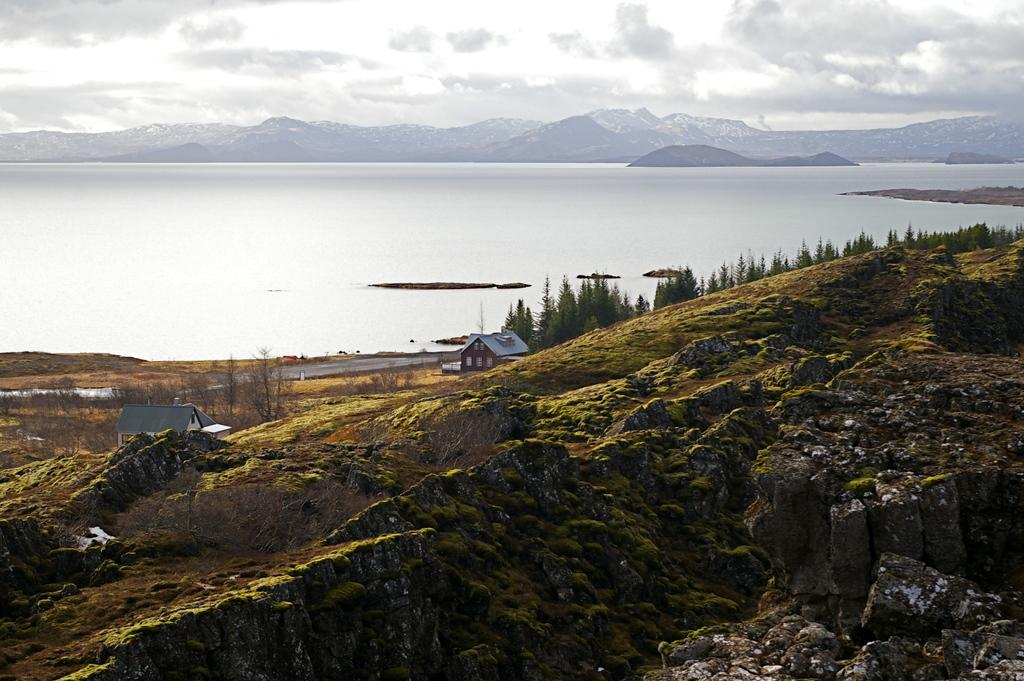What type of vegetation can be seen on the mountain in the image? There is algae on the mountain in the image. What type of structures are present in the image? There are huts in the image. What other natural elements can be seen in the image? There are trees in the image. What can be seen in the background of the image? There is a river, mountains, and the sky visible in the background of the image. Can you see any fairies flying around the huts in the image? There are no fairies present in the image. What type of brass objects can be seen in the image? There is no brass object present in the image. 